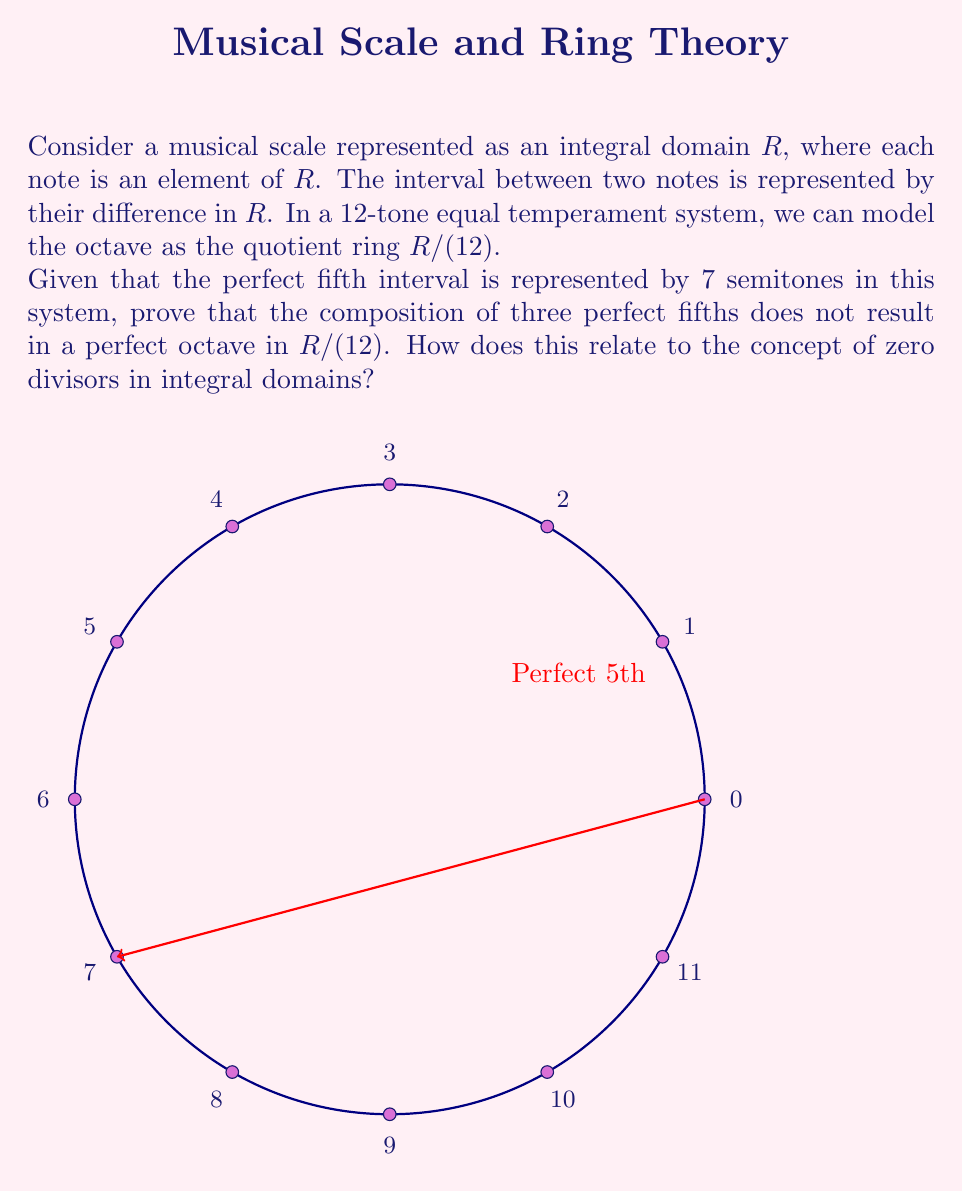Help me with this question. Let's approach this step-by-step:

1) In the 12-tone equal temperament system, we're working in the ring $R/(12)$, which means all calculations are done modulo 12.

2) A perfect fifth is represented by 7 semitones. Let's compose three perfect fifths:

   $7 + 7 + 7 = 21$

3) In $R/(12)$, we have:

   $21 \equiv 21 \mod 12 \equiv 9 \mod 12$

4) This means that three perfect fifths result in an interval of 9 semitones, not 12 (which would be a perfect octave).

5) In an integral domain, there are no zero divisors. This means that if $ab = 0$, then either $a = 0$ or $b = 0$.

6) However, in $R/(12)$, we can find non-zero elements whose product is zero:

   $3 \cdot 4 \equiv 0 \mod 12$

7) This demonstrates that $R/(12)$ is not an integral domain, despite $R$ being an integral domain.

8) The fact that three perfect fifths don't make an octave (3 * 7 ≢ 0 mod 12) is related to the lack of integral domain properties in $R/(12)$. In an integral domain, we would expect that if an element (7 in this case) raised to some power equals the identity (0 mod 12), it must be the identity itself or have an inverse. But 7 is neither 0 nor has an inverse in $R/(12)$.

This phenomenon is known in music theory as the "Pythagorean comma" and is a fundamental issue in tuning systems.
Answer: $R/(12)$ is not an integral domain; $3 \cdot 7 \not\equiv 0 \mod 12$ 